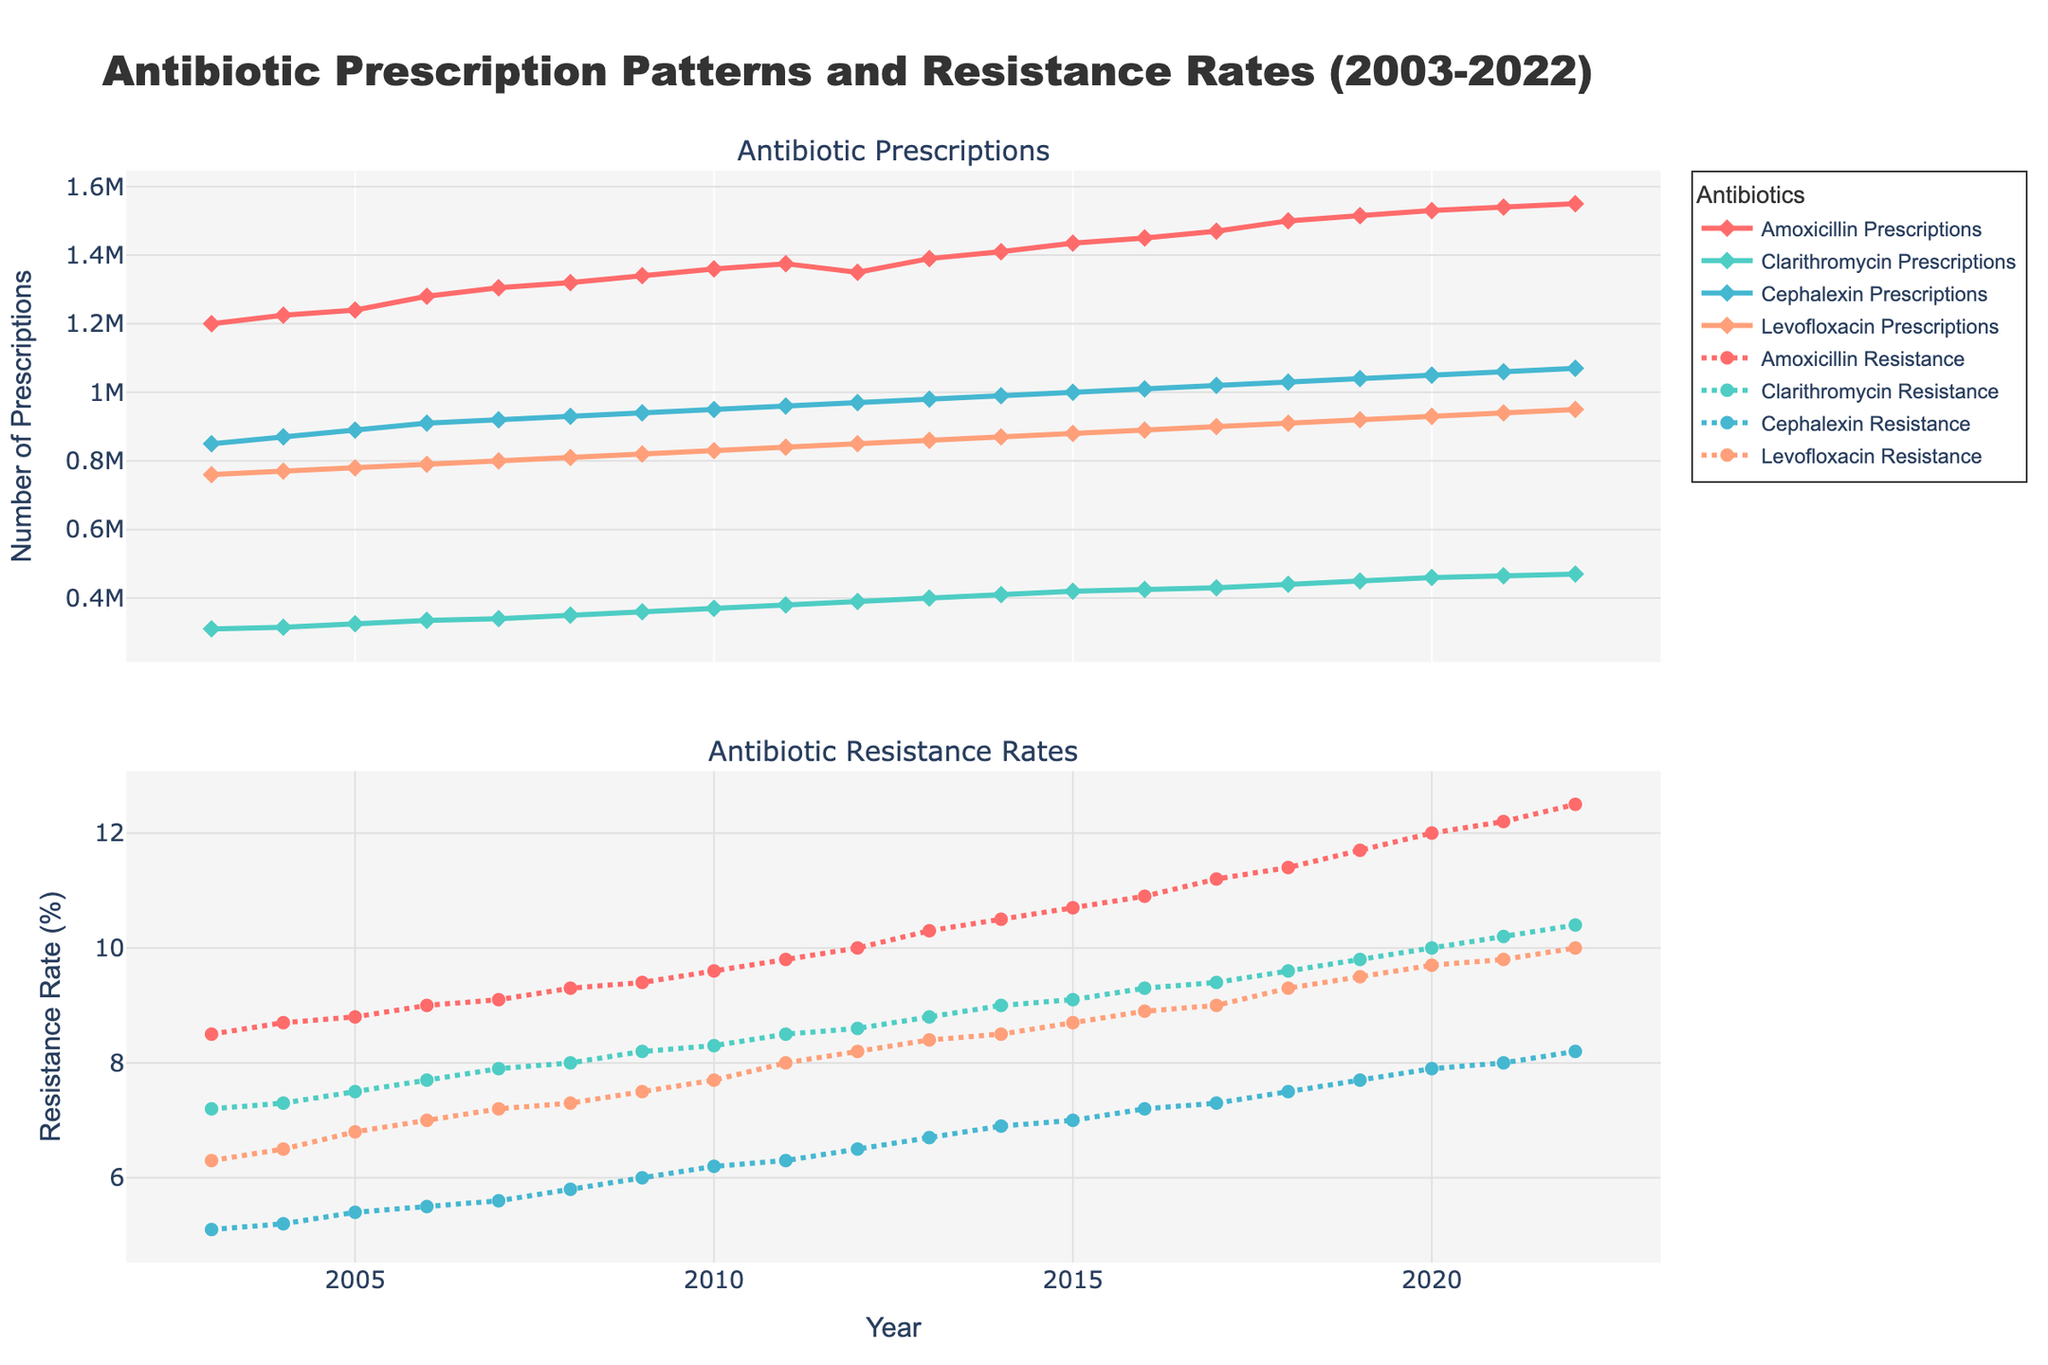What is the title of the figure? The title is located at the top of the figure and typically summarizes what the figure represents.
Answer: Antibiotic Prescription Patterns and Resistance Rates (2003-2022) What antibiotics are tracked in the figure? The legend at the right-hand side of the plot lists the antibiotics being tracked. Each color and marker type corresponds to different antibiotics.
Answer: Amoxicillin, Clarithromycin, Cephalexin, Levofloxacin What are the two subplots shown in the figure? The figure is divided into two sections with titles for each subplot. The upper subplot tracks prescriptions while the lower tracks resistance rates.
Answer: Antibiotic Prescriptions and Antibiotic Resistance Rates Which antibiotic had the highest number of prescriptions in 2022, and what was the value? In the subplot showing prescriptions, follow the trend lines to the year 2022 and identify the highest point.
Answer: Amoxicillin, 1,550,000 How did the resistance rate of Levofloxacin change from 2003 to 2022? On the subplot for resistance rates, locate Levofloxacin and compare the values at the start (2003) and end (2022) of the period.
Answer: Increased from 6.3% to 10.0% What can you say about the trend of Clarithromycin's prescriptions and resistance rates over the years? Looking at both subplots, observe the trend lines for Clarithromycin over time to identify general patterns and changes.
Answer: Both are increasing over time Which antibiotic showed the most rapid increase in resistance rates over the 20 years? Compare the slopes of the resistance rate lines for all antibiotics to determine which has the steepest increase.
Answer: Amoxicillin In what year did Cephalexin's resistance rate reach 8%? Trace the resistance rate line for Cephalexin on the lower subplot and find the year where it intersects the 8% level.
Answer: 2022 Compare the resistance rates of Clarithromycin and Cephalexin in 2010. Which was higher? Locate the year 2010 on the resistance rate subplot and compare the points for Clarithromycin and Cephalexin.
Answer: Clarithromycin Between which years did Amoxicillin see its largest increase in prescriptions? On the prescriptions subplot, compare the differences year-over-year for Amoxicillin to find the largest increase.
Answer: 2018 to 2019 